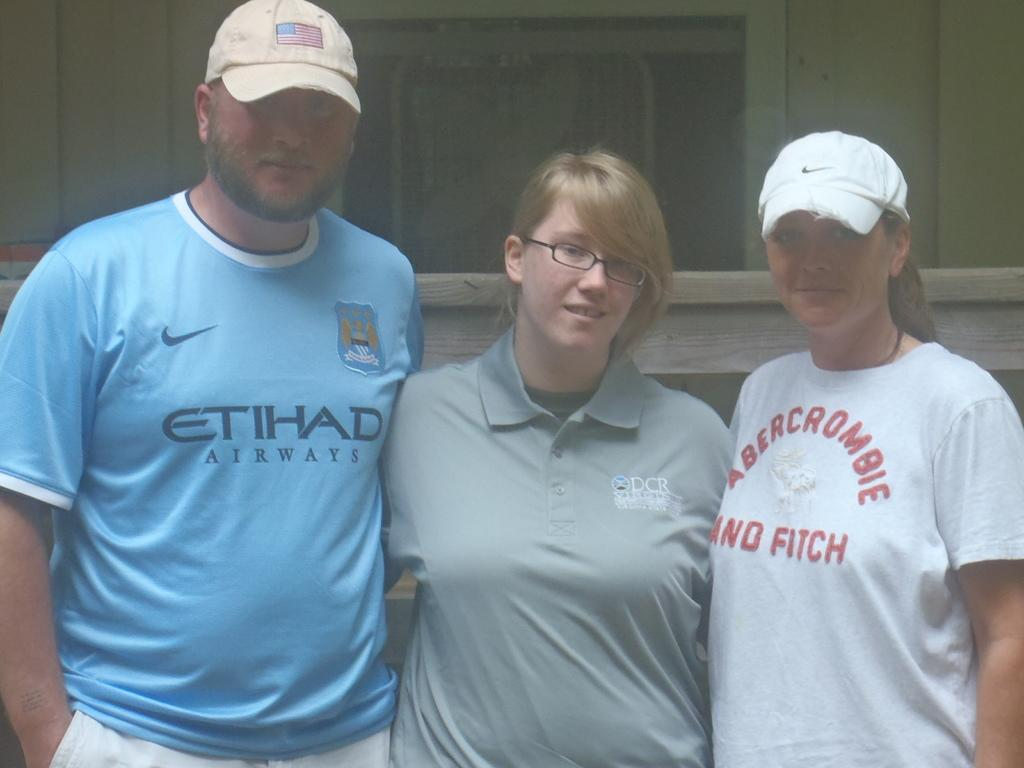<image>
Write a terse but informative summary of the picture. Man posing with other people while wearing a blue shirt that says ETIHAD. 